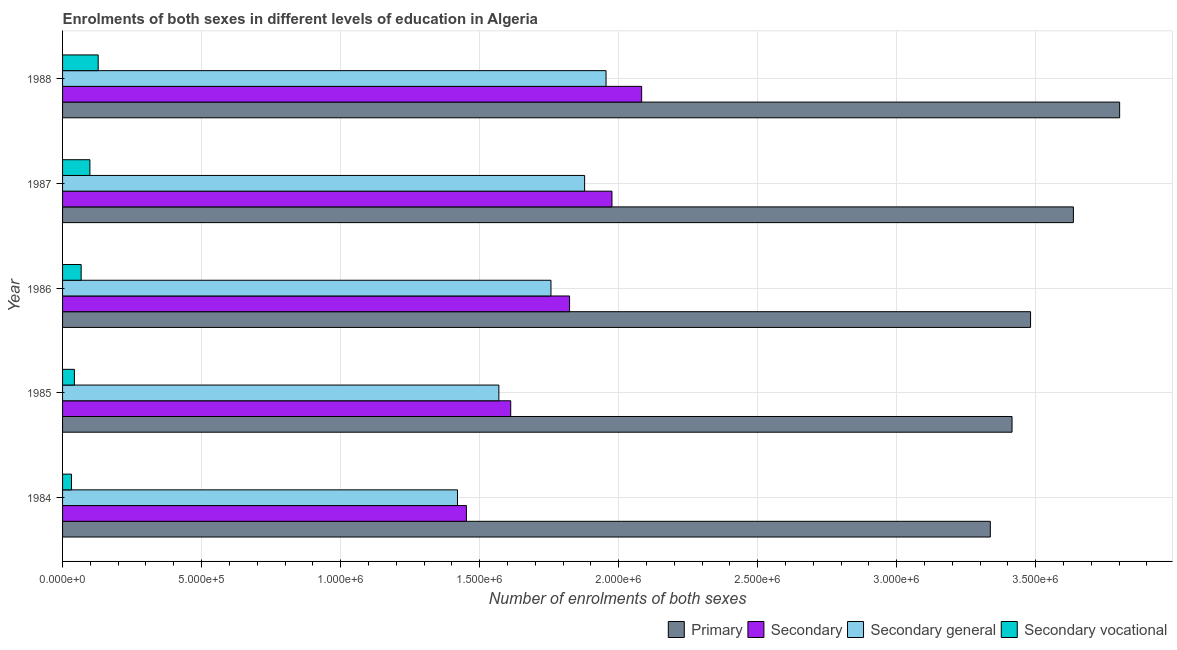Are the number of bars per tick equal to the number of legend labels?
Keep it short and to the point. Yes. What is the label of the 4th group of bars from the top?
Ensure brevity in your answer.  1985. In how many cases, is the number of bars for a given year not equal to the number of legend labels?
Keep it short and to the point. 0. What is the number of enrolments in secondary education in 1985?
Offer a terse response. 1.61e+06. Across all years, what is the maximum number of enrolments in secondary general education?
Your response must be concise. 1.95e+06. Across all years, what is the minimum number of enrolments in secondary vocational education?
Provide a succinct answer. 3.21e+04. In which year was the number of enrolments in secondary education maximum?
Provide a succinct answer. 1988. In which year was the number of enrolments in secondary general education minimum?
Your answer should be compact. 1984. What is the total number of enrolments in secondary general education in the graph?
Provide a succinct answer. 8.58e+06. What is the difference between the number of enrolments in secondary vocational education in 1984 and that in 1986?
Your answer should be compact. -3.48e+04. What is the difference between the number of enrolments in secondary general education in 1987 and the number of enrolments in secondary vocational education in 1986?
Give a very brief answer. 1.81e+06. What is the average number of enrolments in secondary general education per year?
Make the answer very short. 1.72e+06. In the year 1986, what is the difference between the number of enrolments in secondary general education and number of enrolments in primary education?
Your response must be concise. -1.72e+06. What is the ratio of the number of enrolments in secondary general education in 1986 to that in 1987?
Your answer should be compact. 0.94. Is the difference between the number of enrolments in secondary general education in 1985 and 1987 greater than the difference between the number of enrolments in secondary vocational education in 1985 and 1987?
Keep it short and to the point. No. What is the difference between the highest and the second highest number of enrolments in secondary general education?
Ensure brevity in your answer.  7.70e+04. What is the difference between the highest and the lowest number of enrolments in secondary general education?
Your response must be concise. 5.34e+05. In how many years, is the number of enrolments in primary education greater than the average number of enrolments in primary education taken over all years?
Your response must be concise. 2. What does the 1st bar from the top in 1985 represents?
Your answer should be very brief. Secondary vocational. What does the 4th bar from the bottom in 1987 represents?
Your answer should be compact. Secondary vocational. Is it the case that in every year, the sum of the number of enrolments in primary education and number of enrolments in secondary education is greater than the number of enrolments in secondary general education?
Your response must be concise. Yes. How many bars are there?
Provide a succinct answer. 20. How many years are there in the graph?
Provide a short and direct response. 5. What is the difference between two consecutive major ticks on the X-axis?
Offer a terse response. 5.00e+05. Are the values on the major ticks of X-axis written in scientific E-notation?
Give a very brief answer. Yes. Where does the legend appear in the graph?
Provide a succinct answer. Bottom right. What is the title of the graph?
Provide a short and direct response. Enrolments of both sexes in different levels of education in Algeria. What is the label or title of the X-axis?
Your answer should be compact. Number of enrolments of both sexes. What is the Number of enrolments of both sexes in Primary in 1984?
Your answer should be compact. 3.34e+06. What is the Number of enrolments of both sexes of Secondary in 1984?
Offer a very short reply. 1.45e+06. What is the Number of enrolments of both sexes in Secondary general in 1984?
Your answer should be very brief. 1.42e+06. What is the Number of enrolments of both sexes in Secondary vocational in 1984?
Keep it short and to the point. 3.21e+04. What is the Number of enrolments of both sexes of Primary in 1985?
Provide a succinct answer. 3.41e+06. What is the Number of enrolments of both sexes in Secondary in 1985?
Your answer should be compact. 1.61e+06. What is the Number of enrolments of both sexes in Secondary general in 1985?
Give a very brief answer. 1.57e+06. What is the Number of enrolments of both sexes in Secondary vocational in 1985?
Keep it short and to the point. 4.26e+04. What is the Number of enrolments of both sexes in Primary in 1986?
Your answer should be compact. 3.48e+06. What is the Number of enrolments of both sexes of Secondary in 1986?
Your response must be concise. 1.82e+06. What is the Number of enrolments of both sexes of Secondary general in 1986?
Make the answer very short. 1.76e+06. What is the Number of enrolments of both sexes of Secondary vocational in 1986?
Keep it short and to the point. 6.69e+04. What is the Number of enrolments of both sexes of Primary in 1987?
Offer a very short reply. 3.64e+06. What is the Number of enrolments of both sexes of Secondary in 1987?
Offer a very short reply. 1.98e+06. What is the Number of enrolments of both sexes of Secondary general in 1987?
Give a very brief answer. 1.88e+06. What is the Number of enrolments of both sexes in Secondary vocational in 1987?
Provide a succinct answer. 9.83e+04. What is the Number of enrolments of both sexes in Primary in 1988?
Your answer should be very brief. 3.80e+06. What is the Number of enrolments of both sexes of Secondary in 1988?
Give a very brief answer. 2.08e+06. What is the Number of enrolments of both sexes in Secondary general in 1988?
Make the answer very short. 1.95e+06. What is the Number of enrolments of both sexes in Secondary vocational in 1988?
Your answer should be compact. 1.28e+05. Across all years, what is the maximum Number of enrolments of both sexes of Primary?
Provide a succinct answer. 3.80e+06. Across all years, what is the maximum Number of enrolments of both sexes of Secondary?
Your answer should be very brief. 2.08e+06. Across all years, what is the maximum Number of enrolments of both sexes of Secondary general?
Your response must be concise. 1.95e+06. Across all years, what is the maximum Number of enrolments of both sexes in Secondary vocational?
Ensure brevity in your answer.  1.28e+05. Across all years, what is the minimum Number of enrolments of both sexes of Primary?
Offer a terse response. 3.34e+06. Across all years, what is the minimum Number of enrolments of both sexes of Secondary?
Provide a short and direct response. 1.45e+06. Across all years, what is the minimum Number of enrolments of both sexes of Secondary general?
Your answer should be compact. 1.42e+06. Across all years, what is the minimum Number of enrolments of both sexes of Secondary vocational?
Offer a terse response. 3.21e+04. What is the total Number of enrolments of both sexes of Primary in the graph?
Offer a terse response. 1.77e+07. What is the total Number of enrolments of both sexes of Secondary in the graph?
Provide a short and direct response. 8.95e+06. What is the total Number of enrolments of both sexes of Secondary general in the graph?
Give a very brief answer. 8.58e+06. What is the total Number of enrolments of both sexes in Secondary vocational in the graph?
Ensure brevity in your answer.  3.68e+05. What is the difference between the Number of enrolments of both sexes in Primary in 1984 and that in 1985?
Provide a short and direct response. -7.82e+04. What is the difference between the Number of enrolments of both sexes in Secondary in 1984 and that in 1985?
Provide a succinct answer. -1.59e+05. What is the difference between the Number of enrolments of both sexes of Secondary general in 1984 and that in 1985?
Give a very brief answer. -1.49e+05. What is the difference between the Number of enrolments of both sexes in Secondary vocational in 1984 and that in 1985?
Ensure brevity in your answer.  -1.05e+04. What is the difference between the Number of enrolments of both sexes in Primary in 1984 and that in 1986?
Offer a terse response. -1.45e+05. What is the difference between the Number of enrolments of both sexes of Secondary in 1984 and that in 1986?
Give a very brief answer. -3.71e+05. What is the difference between the Number of enrolments of both sexes in Secondary general in 1984 and that in 1986?
Give a very brief answer. -3.36e+05. What is the difference between the Number of enrolments of both sexes of Secondary vocational in 1984 and that in 1986?
Give a very brief answer. -3.48e+04. What is the difference between the Number of enrolments of both sexes of Primary in 1984 and that in 1987?
Give a very brief answer. -2.99e+05. What is the difference between the Number of enrolments of both sexes of Secondary in 1984 and that in 1987?
Your response must be concise. -5.23e+05. What is the difference between the Number of enrolments of both sexes of Secondary general in 1984 and that in 1987?
Ensure brevity in your answer.  -4.57e+05. What is the difference between the Number of enrolments of both sexes in Secondary vocational in 1984 and that in 1987?
Keep it short and to the point. -6.62e+04. What is the difference between the Number of enrolments of both sexes of Primary in 1984 and that in 1988?
Your answer should be very brief. -4.65e+05. What is the difference between the Number of enrolments of both sexes of Secondary in 1984 and that in 1988?
Your response must be concise. -6.30e+05. What is the difference between the Number of enrolments of both sexes of Secondary general in 1984 and that in 1988?
Keep it short and to the point. -5.34e+05. What is the difference between the Number of enrolments of both sexes of Secondary vocational in 1984 and that in 1988?
Provide a succinct answer. -9.60e+04. What is the difference between the Number of enrolments of both sexes in Primary in 1985 and that in 1986?
Give a very brief answer. -6.66e+04. What is the difference between the Number of enrolments of both sexes of Secondary in 1985 and that in 1986?
Offer a terse response. -2.12e+05. What is the difference between the Number of enrolments of both sexes of Secondary general in 1985 and that in 1986?
Provide a succinct answer. -1.87e+05. What is the difference between the Number of enrolments of both sexes of Secondary vocational in 1985 and that in 1986?
Make the answer very short. -2.43e+04. What is the difference between the Number of enrolments of both sexes in Primary in 1985 and that in 1987?
Your response must be concise. -2.21e+05. What is the difference between the Number of enrolments of both sexes of Secondary in 1985 and that in 1987?
Provide a short and direct response. -3.64e+05. What is the difference between the Number of enrolments of both sexes in Secondary general in 1985 and that in 1987?
Your response must be concise. -3.08e+05. What is the difference between the Number of enrolments of both sexes of Secondary vocational in 1985 and that in 1987?
Make the answer very short. -5.57e+04. What is the difference between the Number of enrolments of both sexes of Primary in 1985 and that in 1988?
Give a very brief answer. -3.87e+05. What is the difference between the Number of enrolments of both sexes of Secondary in 1985 and that in 1988?
Your answer should be very brief. -4.71e+05. What is the difference between the Number of enrolments of both sexes in Secondary general in 1985 and that in 1988?
Offer a terse response. -3.85e+05. What is the difference between the Number of enrolments of both sexes in Secondary vocational in 1985 and that in 1988?
Offer a very short reply. -8.55e+04. What is the difference between the Number of enrolments of both sexes of Primary in 1986 and that in 1987?
Keep it short and to the point. -1.54e+05. What is the difference between the Number of enrolments of both sexes of Secondary in 1986 and that in 1987?
Keep it short and to the point. -1.52e+05. What is the difference between the Number of enrolments of both sexes in Secondary general in 1986 and that in 1987?
Give a very brief answer. -1.21e+05. What is the difference between the Number of enrolments of both sexes in Secondary vocational in 1986 and that in 1987?
Provide a short and direct response. -3.14e+04. What is the difference between the Number of enrolments of both sexes in Primary in 1986 and that in 1988?
Offer a very short reply. -3.20e+05. What is the difference between the Number of enrolments of both sexes in Secondary in 1986 and that in 1988?
Make the answer very short. -2.59e+05. What is the difference between the Number of enrolments of both sexes in Secondary general in 1986 and that in 1988?
Make the answer very short. -1.98e+05. What is the difference between the Number of enrolments of both sexes of Secondary vocational in 1986 and that in 1988?
Offer a very short reply. -6.12e+04. What is the difference between the Number of enrolments of both sexes in Primary in 1987 and that in 1988?
Keep it short and to the point. -1.66e+05. What is the difference between the Number of enrolments of both sexes in Secondary in 1987 and that in 1988?
Keep it short and to the point. -1.07e+05. What is the difference between the Number of enrolments of both sexes in Secondary general in 1987 and that in 1988?
Make the answer very short. -7.70e+04. What is the difference between the Number of enrolments of both sexes of Secondary vocational in 1987 and that in 1988?
Make the answer very short. -2.98e+04. What is the difference between the Number of enrolments of both sexes of Primary in 1984 and the Number of enrolments of both sexes of Secondary in 1985?
Offer a terse response. 1.72e+06. What is the difference between the Number of enrolments of both sexes of Primary in 1984 and the Number of enrolments of both sexes of Secondary general in 1985?
Your answer should be compact. 1.77e+06. What is the difference between the Number of enrolments of both sexes of Primary in 1984 and the Number of enrolments of both sexes of Secondary vocational in 1985?
Offer a terse response. 3.29e+06. What is the difference between the Number of enrolments of both sexes of Secondary in 1984 and the Number of enrolments of both sexes of Secondary general in 1985?
Provide a succinct answer. -1.17e+05. What is the difference between the Number of enrolments of both sexes of Secondary in 1984 and the Number of enrolments of both sexes of Secondary vocational in 1985?
Provide a succinct answer. 1.41e+06. What is the difference between the Number of enrolments of both sexes in Secondary general in 1984 and the Number of enrolments of both sexes in Secondary vocational in 1985?
Your answer should be very brief. 1.38e+06. What is the difference between the Number of enrolments of both sexes in Primary in 1984 and the Number of enrolments of both sexes in Secondary in 1986?
Your answer should be compact. 1.51e+06. What is the difference between the Number of enrolments of both sexes in Primary in 1984 and the Number of enrolments of both sexes in Secondary general in 1986?
Your response must be concise. 1.58e+06. What is the difference between the Number of enrolments of both sexes of Primary in 1984 and the Number of enrolments of both sexes of Secondary vocational in 1986?
Your response must be concise. 3.27e+06. What is the difference between the Number of enrolments of both sexes in Secondary in 1984 and the Number of enrolments of both sexes in Secondary general in 1986?
Offer a very short reply. -3.04e+05. What is the difference between the Number of enrolments of both sexes in Secondary in 1984 and the Number of enrolments of both sexes in Secondary vocational in 1986?
Offer a very short reply. 1.39e+06. What is the difference between the Number of enrolments of both sexes in Secondary general in 1984 and the Number of enrolments of both sexes in Secondary vocational in 1986?
Your answer should be very brief. 1.35e+06. What is the difference between the Number of enrolments of both sexes of Primary in 1984 and the Number of enrolments of both sexes of Secondary in 1987?
Your response must be concise. 1.36e+06. What is the difference between the Number of enrolments of both sexes of Primary in 1984 and the Number of enrolments of both sexes of Secondary general in 1987?
Offer a very short reply. 1.46e+06. What is the difference between the Number of enrolments of both sexes of Primary in 1984 and the Number of enrolments of both sexes of Secondary vocational in 1987?
Offer a very short reply. 3.24e+06. What is the difference between the Number of enrolments of both sexes of Secondary in 1984 and the Number of enrolments of both sexes of Secondary general in 1987?
Offer a very short reply. -4.25e+05. What is the difference between the Number of enrolments of both sexes in Secondary in 1984 and the Number of enrolments of both sexes in Secondary vocational in 1987?
Give a very brief answer. 1.35e+06. What is the difference between the Number of enrolments of both sexes of Secondary general in 1984 and the Number of enrolments of both sexes of Secondary vocational in 1987?
Provide a short and direct response. 1.32e+06. What is the difference between the Number of enrolments of both sexes of Primary in 1984 and the Number of enrolments of both sexes of Secondary in 1988?
Keep it short and to the point. 1.25e+06. What is the difference between the Number of enrolments of both sexes of Primary in 1984 and the Number of enrolments of both sexes of Secondary general in 1988?
Keep it short and to the point. 1.38e+06. What is the difference between the Number of enrolments of both sexes of Primary in 1984 and the Number of enrolments of both sexes of Secondary vocational in 1988?
Ensure brevity in your answer.  3.21e+06. What is the difference between the Number of enrolments of both sexes in Secondary in 1984 and the Number of enrolments of both sexes in Secondary general in 1988?
Give a very brief answer. -5.02e+05. What is the difference between the Number of enrolments of both sexes of Secondary in 1984 and the Number of enrolments of both sexes of Secondary vocational in 1988?
Your answer should be compact. 1.32e+06. What is the difference between the Number of enrolments of both sexes of Secondary general in 1984 and the Number of enrolments of both sexes of Secondary vocational in 1988?
Keep it short and to the point. 1.29e+06. What is the difference between the Number of enrolments of both sexes in Primary in 1985 and the Number of enrolments of both sexes in Secondary in 1986?
Provide a short and direct response. 1.59e+06. What is the difference between the Number of enrolments of both sexes of Primary in 1985 and the Number of enrolments of both sexes of Secondary general in 1986?
Offer a terse response. 1.66e+06. What is the difference between the Number of enrolments of both sexes of Primary in 1985 and the Number of enrolments of both sexes of Secondary vocational in 1986?
Your response must be concise. 3.35e+06. What is the difference between the Number of enrolments of both sexes in Secondary in 1985 and the Number of enrolments of both sexes in Secondary general in 1986?
Offer a terse response. -1.45e+05. What is the difference between the Number of enrolments of both sexes in Secondary in 1985 and the Number of enrolments of both sexes in Secondary vocational in 1986?
Make the answer very short. 1.54e+06. What is the difference between the Number of enrolments of both sexes in Secondary general in 1985 and the Number of enrolments of both sexes in Secondary vocational in 1986?
Make the answer very short. 1.50e+06. What is the difference between the Number of enrolments of both sexes of Primary in 1985 and the Number of enrolments of both sexes of Secondary in 1987?
Provide a short and direct response. 1.44e+06. What is the difference between the Number of enrolments of both sexes of Primary in 1985 and the Number of enrolments of both sexes of Secondary general in 1987?
Offer a terse response. 1.54e+06. What is the difference between the Number of enrolments of both sexes in Primary in 1985 and the Number of enrolments of both sexes in Secondary vocational in 1987?
Your answer should be very brief. 3.32e+06. What is the difference between the Number of enrolments of both sexes of Secondary in 1985 and the Number of enrolments of both sexes of Secondary general in 1987?
Give a very brief answer. -2.66e+05. What is the difference between the Number of enrolments of both sexes in Secondary in 1985 and the Number of enrolments of both sexes in Secondary vocational in 1987?
Your answer should be compact. 1.51e+06. What is the difference between the Number of enrolments of both sexes of Secondary general in 1985 and the Number of enrolments of both sexes of Secondary vocational in 1987?
Provide a succinct answer. 1.47e+06. What is the difference between the Number of enrolments of both sexes in Primary in 1985 and the Number of enrolments of both sexes in Secondary in 1988?
Your response must be concise. 1.33e+06. What is the difference between the Number of enrolments of both sexes of Primary in 1985 and the Number of enrolments of both sexes of Secondary general in 1988?
Your answer should be compact. 1.46e+06. What is the difference between the Number of enrolments of both sexes in Primary in 1985 and the Number of enrolments of both sexes in Secondary vocational in 1988?
Offer a very short reply. 3.29e+06. What is the difference between the Number of enrolments of both sexes of Secondary in 1985 and the Number of enrolments of both sexes of Secondary general in 1988?
Make the answer very short. -3.43e+05. What is the difference between the Number of enrolments of both sexes in Secondary in 1985 and the Number of enrolments of both sexes in Secondary vocational in 1988?
Keep it short and to the point. 1.48e+06. What is the difference between the Number of enrolments of both sexes of Secondary general in 1985 and the Number of enrolments of both sexes of Secondary vocational in 1988?
Keep it short and to the point. 1.44e+06. What is the difference between the Number of enrolments of both sexes in Primary in 1986 and the Number of enrolments of both sexes in Secondary in 1987?
Give a very brief answer. 1.51e+06. What is the difference between the Number of enrolments of both sexes of Primary in 1986 and the Number of enrolments of both sexes of Secondary general in 1987?
Provide a succinct answer. 1.60e+06. What is the difference between the Number of enrolments of both sexes in Primary in 1986 and the Number of enrolments of both sexes in Secondary vocational in 1987?
Provide a short and direct response. 3.38e+06. What is the difference between the Number of enrolments of both sexes of Secondary in 1986 and the Number of enrolments of both sexes of Secondary general in 1987?
Your answer should be very brief. -5.42e+04. What is the difference between the Number of enrolments of both sexes of Secondary in 1986 and the Number of enrolments of both sexes of Secondary vocational in 1987?
Ensure brevity in your answer.  1.73e+06. What is the difference between the Number of enrolments of both sexes of Secondary general in 1986 and the Number of enrolments of both sexes of Secondary vocational in 1987?
Offer a very short reply. 1.66e+06. What is the difference between the Number of enrolments of both sexes in Primary in 1986 and the Number of enrolments of both sexes in Secondary in 1988?
Your response must be concise. 1.40e+06. What is the difference between the Number of enrolments of both sexes of Primary in 1986 and the Number of enrolments of both sexes of Secondary general in 1988?
Provide a succinct answer. 1.53e+06. What is the difference between the Number of enrolments of both sexes in Primary in 1986 and the Number of enrolments of both sexes in Secondary vocational in 1988?
Keep it short and to the point. 3.35e+06. What is the difference between the Number of enrolments of both sexes of Secondary in 1986 and the Number of enrolments of both sexes of Secondary general in 1988?
Give a very brief answer. -1.31e+05. What is the difference between the Number of enrolments of both sexes of Secondary in 1986 and the Number of enrolments of both sexes of Secondary vocational in 1988?
Provide a succinct answer. 1.70e+06. What is the difference between the Number of enrolments of both sexes in Secondary general in 1986 and the Number of enrolments of both sexes in Secondary vocational in 1988?
Keep it short and to the point. 1.63e+06. What is the difference between the Number of enrolments of both sexes of Primary in 1987 and the Number of enrolments of both sexes of Secondary in 1988?
Provide a short and direct response. 1.55e+06. What is the difference between the Number of enrolments of both sexes in Primary in 1987 and the Number of enrolments of both sexes in Secondary general in 1988?
Your answer should be very brief. 1.68e+06. What is the difference between the Number of enrolments of both sexes of Primary in 1987 and the Number of enrolments of both sexes of Secondary vocational in 1988?
Your answer should be very brief. 3.51e+06. What is the difference between the Number of enrolments of both sexes in Secondary in 1987 and the Number of enrolments of both sexes in Secondary general in 1988?
Give a very brief answer. 2.13e+04. What is the difference between the Number of enrolments of both sexes in Secondary in 1987 and the Number of enrolments of both sexes in Secondary vocational in 1988?
Make the answer very short. 1.85e+06. What is the difference between the Number of enrolments of both sexes in Secondary general in 1987 and the Number of enrolments of both sexes in Secondary vocational in 1988?
Give a very brief answer. 1.75e+06. What is the average Number of enrolments of both sexes in Primary per year?
Offer a very short reply. 3.53e+06. What is the average Number of enrolments of both sexes of Secondary per year?
Make the answer very short. 1.79e+06. What is the average Number of enrolments of both sexes of Secondary general per year?
Ensure brevity in your answer.  1.72e+06. What is the average Number of enrolments of both sexes of Secondary vocational per year?
Provide a succinct answer. 7.36e+04. In the year 1984, what is the difference between the Number of enrolments of both sexes in Primary and Number of enrolments of both sexes in Secondary?
Keep it short and to the point. 1.88e+06. In the year 1984, what is the difference between the Number of enrolments of both sexes of Primary and Number of enrolments of both sexes of Secondary general?
Your response must be concise. 1.92e+06. In the year 1984, what is the difference between the Number of enrolments of both sexes in Primary and Number of enrolments of both sexes in Secondary vocational?
Your answer should be compact. 3.30e+06. In the year 1984, what is the difference between the Number of enrolments of both sexes in Secondary and Number of enrolments of both sexes in Secondary general?
Keep it short and to the point. 3.21e+04. In the year 1984, what is the difference between the Number of enrolments of both sexes of Secondary and Number of enrolments of both sexes of Secondary vocational?
Offer a very short reply. 1.42e+06. In the year 1984, what is the difference between the Number of enrolments of both sexes in Secondary general and Number of enrolments of both sexes in Secondary vocational?
Provide a succinct answer. 1.39e+06. In the year 1985, what is the difference between the Number of enrolments of both sexes of Primary and Number of enrolments of both sexes of Secondary?
Offer a terse response. 1.80e+06. In the year 1985, what is the difference between the Number of enrolments of both sexes in Primary and Number of enrolments of both sexes in Secondary general?
Make the answer very short. 1.85e+06. In the year 1985, what is the difference between the Number of enrolments of both sexes of Primary and Number of enrolments of both sexes of Secondary vocational?
Provide a short and direct response. 3.37e+06. In the year 1985, what is the difference between the Number of enrolments of both sexes in Secondary and Number of enrolments of both sexes in Secondary general?
Offer a terse response. 4.26e+04. In the year 1985, what is the difference between the Number of enrolments of both sexes of Secondary and Number of enrolments of both sexes of Secondary vocational?
Provide a short and direct response. 1.57e+06. In the year 1985, what is the difference between the Number of enrolments of both sexes of Secondary general and Number of enrolments of both sexes of Secondary vocational?
Provide a short and direct response. 1.53e+06. In the year 1986, what is the difference between the Number of enrolments of both sexes in Primary and Number of enrolments of both sexes in Secondary?
Your response must be concise. 1.66e+06. In the year 1986, what is the difference between the Number of enrolments of both sexes in Primary and Number of enrolments of both sexes in Secondary general?
Offer a terse response. 1.72e+06. In the year 1986, what is the difference between the Number of enrolments of both sexes of Primary and Number of enrolments of both sexes of Secondary vocational?
Give a very brief answer. 3.41e+06. In the year 1986, what is the difference between the Number of enrolments of both sexes of Secondary and Number of enrolments of both sexes of Secondary general?
Your answer should be very brief. 6.69e+04. In the year 1986, what is the difference between the Number of enrolments of both sexes in Secondary and Number of enrolments of both sexes in Secondary vocational?
Your answer should be very brief. 1.76e+06. In the year 1986, what is the difference between the Number of enrolments of both sexes of Secondary general and Number of enrolments of both sexes of Secondary vocational?
Ensure brevity in your answer.  1.69e+06. In the year 1987, what is the difference between the Number of enrolments of both sexes in Primary and Number of enrolments of both sexes in Secondary?
Make the answer very short. 1.66e+06. In the year 1987, what is the difference between the Number of enrolments of both sexes of Primary and Number of enrolments of both sexes of Secondary general?
Your response must be concise. 1.76e+06. In the year 1987, what is the difference between the Number of enrolments of both sexes in Primary and Number of enrolments of both sexes in Secondary vocational?
Provide a short and direct response. 3.54e+06. In the year 1987, what is the difference between the Number of enrolments of both sexes in Secondary and Number of enrolments of both sexes in Secondary general?
Your answer should be compact. 9.83e+04. In the year 1987, what is the difference between the Number of enrolments of both sexes of Secondary and Number of enrolments of both sexes of Secondary vocational?
Give a very brief answer. 1.88e+06. In the year 1987, what is the difference between the Number of enrolments of both sexes of Secondary general and Number of enrolments of both sexes of Secondary vocational?
Ensure brevity in your answer.  1.78e+06. In the year 1988, what is the difference between the Number of enrolments of both sexes of Primary and Number of enrolments of both sexes of Secondary?
Your answer should be compact. 1.72e+06. In the year 1988, what is the difference between the Number of enrolments of both sexes in Primary and Number of enrolments of both sexes in Secondary general?
Provide a succinct answer. 1.85e+06. In the year 1988, what is the difference between the Number of enrolments of both sexes in Primary and Number of enrolments of both sexes in Secondary vocational?
Ensure brevity in your answer.  3.67e+06. In the year 1988, what is the difference between the Number of enrolments of both sexes of Secondary and Number of enrolments of both sexes of Secondary general?
Give a very brief answer. 1.28e+05. In the year 1988, what is the difference between the Number of enrolments of both sexes in Secondary and Number of enrolments of both sexes in Secondary vocational?
Provide a short and direct response. 1.95e+06. In the year 1988, what is the difference between the Number of enrolments of both sexes in Secondary general and Number of enrolments of both sexes in Secondary vocational?
Offer a very short reply. 1.83e+06. What is the ratio of the Number of enrolments of both sexes of Primary in 1984 to that in 1985?
Ensure brevity in your answer.  0.98. What is the ratio of the Number of enrolments of both sexes of Secondary in 1984 to that in 1985?
Give a very brief answer. 0.9. What is the ratio of the Number of enrolments of both sexes in Secondary general in 1984 to that in 1985?
Provide a succinct answer. 0.91. What is the ratio of the Number of enrolments of both sexes in Secondary vocational in 1984 to that in 1985?
Make the answer very short. 0.75. What is the ratio of the Number of enrolments of both sexes in Primary in 1984 to that in 1986?
Ensure brevity in your answer.  0.96. What is the ratio of the Number of enrolments of both sexes in Secondary in 1984 to that in 1986?
Provide a short and direct response. 0.8. What is the ratio of the Number of enrolments of both sexes of Secondary general in 1984 to that in 1986?
Your response must be concise. 0.81. What is the ratio of the Number of enrolments of both sexes of Secondary vocational in 1984 to that in 1986?
Your response must be concise. 0.48. What is the ratio of the Number of enrolments of both sexes in Primary in 1984 to that in 1987?
Provide a succinct answer. 0.92. What is the ratio of the Number of enrolments of both sexes in Secondary in 1984 to that in 1987?
Your response must be concise. 0.74. What is the ratio of the Number of enrolments of both sexes in Secondary general in 1984 to that in 1987?
Keep it short and to the point. 0.76. What is the ratio of the Number of enrolments of both sexes of Secondary vocational in 1984 to that in 1987?
Provide a short and direct response. 0.33. What is the ratio of the Number of enrolments of both sexes of Primary in 1984 to that in 1988?
Make the answer very short. 0.88. What is the ratio of the Number of enrolments of both sexes in Secondary in 1984 to that in 1988?
Your answer should be compact. 0.7. What is the ratio of the Number of enrolments of both sexes of Secondary general in 1984 to that in 1988?
Ensure brevity in your answer.  0.73. What is the ratio of the Number of enrolments of both sexes in Secondary vocational in 1984 to that in 1988?
Give a very brief answer. 0.25. What is the ratio of the Number of enrolments of both sexes of Primary in 1985 to that in 1986?
Give a very brief answer. 0.98. What is the ratio of the Number of enrolments of both sexes of Secondary in 1985 to that in 1986?
Your answer should be very brief. 0.88. What is the ratio of the Number of enrolments of both sexes in Secondary general in 1985 to that in 1986?
Keep it short and to the point. 0.89. What is the ratio of the Number of enrolments of both sexes in Secondary vocational in 1985 to that in 1986?
Ensure brevity in your answer.  0.64. What is the ratio of the Number of enrolments of both sexes in Primary in 1985 to that in 1987?
Keep it short and to the point. 0.94. What is the ratio of the Number of enrolments of both sexes of Secondary in 1985 to that in 1987?
Give a very brief answer. 0.82. What is the ratio of the Number of enrolments of both sexes of Secondary general in 1985 to that in 1987?
Provide a short and direct response. 0.84. What is the ratio of the Number of enrolments of both sexes of Secondary vocational in 1985 to that in 1987?
Provide a short and direct response. 0.43. What is the ratio of the Number of enrolments of both sexes in Primary in 1985 to that in 1988?
Provide a succinct answer. 0.9. What is the ratio of the Number of enrolments of both sexes of Secondary in 1985 to that in 1988?
Offer a very short reply. 0.77. What is the ratio of the Number of enrolments of both sexes in Secondary general in 1985 to that in 1988?
Offer a very short reply. 0.8. What is the ratio of the Number of enrolments of both sexes in Secondary vocational in 1985 to that in 1988?
Provide a succinct answer. 0.33. What is the ratio of the Number of enrolments of both sexes in Primary in 1986 to that in 1987?
Provide a succinct answer. 0.96. What is the ratio of the Number of enrolments of both sexes in Secondary in 1986 to that in 1987?
Make the answer very short. 0.92. What is the ratio of the Number of enrolments of both sexes of Secondary general in 1986 to that in 1987?
Offer a terse response. 0.94. What is the ratio of the Number of enrolments of both sexes of Secondary vocational in 1986 to that in 1987?
Offer a terse response. 0.68. What is the ratio of the Number of enrolments of both sexes of Primary in 1986 to that in 1988?
Offer a very short reply. 0.92. What is the ratio of the Number of enrolments of both sexes in Secondary in 1986 to that in 1988?
Your answer should be very brief. 0.88. What is the ratio of the Number of enrolments of both sexes in Secondary general in 1986 to that in 1988?
Offer a terse response. 0.9. What is the ratio of the Number of enrolments of both sexes of Secondary vocational in 1986 to that in 1988?
Your answer should be compact. 0.52. What is the ratio of the Number of enrolments of both sexes in Primary in 1987 to that in 1988?
Give a very brief answer. 0.96. What is the ratio of the Number of enrolments of both sexes in Secondary in 1987 to that in 1988?
Offer a very short reply. 0.95. What is the ratio of the Number of enrolments of both sexes of Secondary general in 1987 to that in 1988?
Provide a succinct answer. 0.96. What is the ratio of the Number of enrolments of both sexes in Secondary vocational in 1987 to that in 1988?
Keep it short and to the point. 0.77. What is the difference between the highest and the second highest Number of enrolments of both sexes of Primary?
Your answer should be very brief. 1.66e+05. What is the difference between the highest and the second highest Number of enrolments of both sexes of Secondary?
Your answer should be very brief. 1.07e+05. What is the difference between the highest and the second highest Number of enrolments of both sexes in Secondary general?
Your answer should be compact. 7.70e+04. What is the difference between the highest and the second highest Number of enrolments of both sexes of Secondary vocational?
Provide a short and direct response. 2.98e+04. What is the difference between the highest and the lowest Number of enrolments of both sexes of Primary?
Make the answer very short. 4.65e+05. What is the difference between the highest and the lowest Number of enrolments of both sexes of Secondary?
Your answer should be very brief. 6.30e+05. What is the difference between the highest and the lowest Number of enrolments of both sexes in Secondary general?
Make the answer very short. 5.34e+05. What is the difference between the highest and the lowest Number of enrolments of both sexes of Secondary vocational?
Your answer should be very brief. 9.60e+04. 